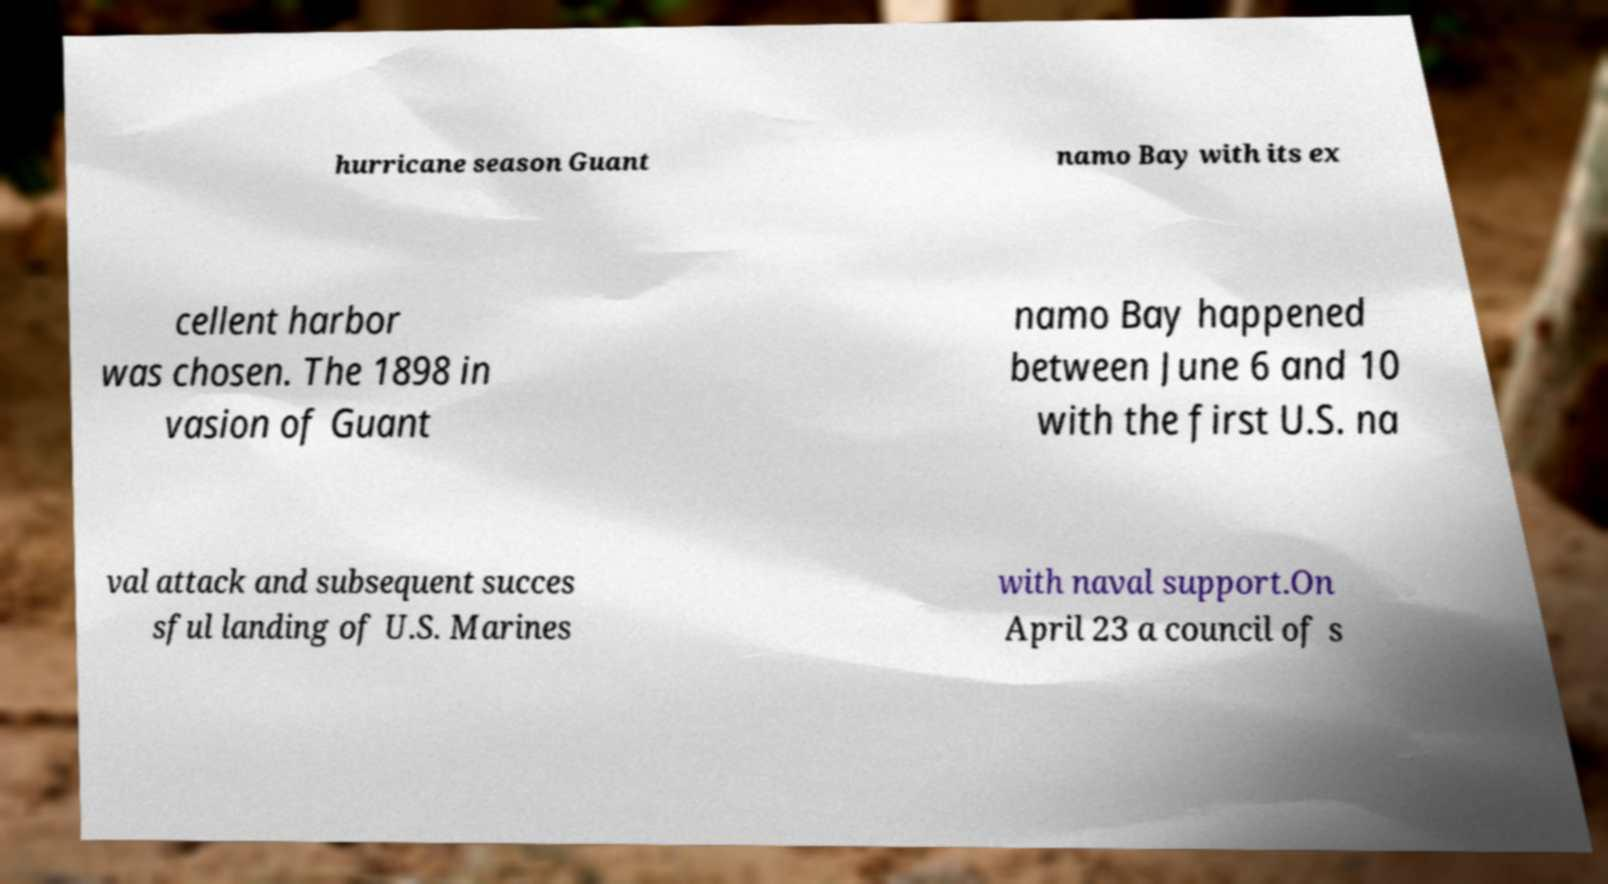What messages or text are displayed in this image? I need them in a readable, typed format. hurricane season Guant namo Bay with its ex cellent harbor was chosen. The 1898 in vasion of Guant namo Bay happened between June 6 and 10 with the first U.S. na val attack and subsequent succes sful landing of U.S. Marines with naval support.On April 23 a council of s 